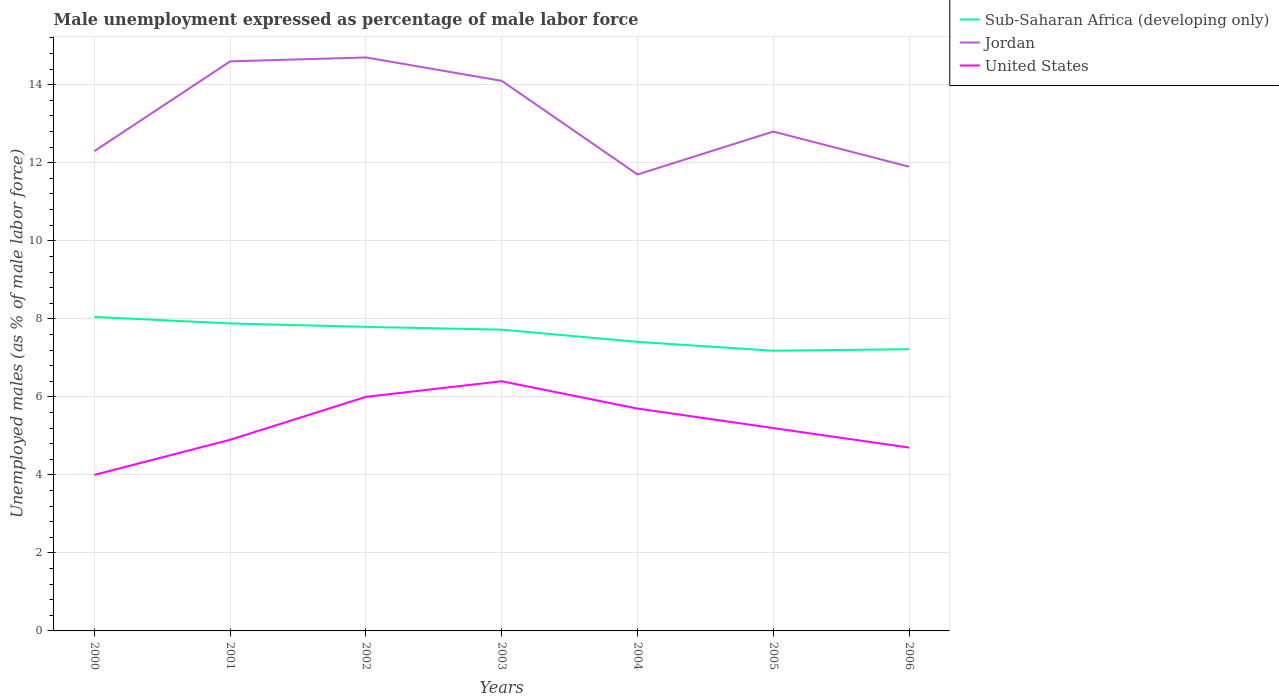How many different coloured lines are there?
Make the answer very short. 3. Across all years, what is the maximum unemployment in males in in Jordan?
Your answer should be compact. 11.7. What is the total unemployment in males in in Sub-Saharan Africa (developing only) in the graph?
Your answer should be compact. 0.09. What is the difference between the highest and the lowest unemployment in males in in Jordan?
Offer a terse response. 3. How many lines are there?
Your answer should be very brief. 3. How many years are there in the graph?
Give a very brief answer. 7. What is the difference between two consecutive major ticks on the Y-axis?
Your answer should be very brief. 2. Does the graph contain any zero values?
Provide a succinct answer. No. How many legend labels are there?
Your response must be concise. 3. How are the legend labels stacked?
Offer a very short reply. Vertical. What is the title of the graph?
Offer a terse response. Male unemployment expressed as percentage of male labor force. Does "Middle income" appear as one of the legend labels in the graph?
Give a very brief answer. No. What is the label or title of the Y-axis?
Offer a terse response. Unemployed males (as % of male labor force). What is the Unemployed males (as % of male labor force) of Sub-Saharan Africa (developing only) in 2000?
Make the answer very short. 8.05. What is the Unemployed males (as % of male labor force) of Jordan in 2000?
Your answer should be compact. 12.3. What is the Unemployed males (as % of male labor force) of United States in 2000?
Your answer should be compact. 4. What is the Unemployed males (as % of male labor force) in Sub-Saharan Africa (developing only) in 2001?
Give a very brief answer. 7.88. What is the Unemployed males (as % of male labor force) of Jordan in 2001?
Offer a very short reply. 14.6. What is the Unemployed males (as % of male labor force) of United States in 2001?
Your response must be concise. 4.9. What is the Unemployed males (as % of male labor force) of Sub-Saharan Africa (developing only) in 2002?
Your answer should be very brief. 7.79. What is the Unemployed males (as % of male labor force) of Jordan in 2002?
Your response must be concise. 14.7. What is the Unemployed males (as % of male labor force) of Sub-Saharan Africa (developing only) in 2003?
Provide a succinct answer. 7.72. What is the Unemployed males (as % of male labor force) of Jordan in 2003?
Your answer should be compact. 14.1. What is the Unemployed males (as % of male labor force) of United States in 2003?
Provide a succinct answer. 6.4. What is the Unemployed males (as % of male labor force) of Sub-Saharan Africa (developing only) in 2004?
Make the answer very short. 7.41. What is the Unemployed males (as % of male labor force) in Jordan in 2004?
Provide a short and direct response. 11.7. What is the Unemployed males (as % of male labor force) in United States in 2004?
Give a very brief answer. 5.7. What is the Unemployed males (as % of male labor force) in Sub-Saharan Africa (developing only) in 2005?
Your response must be concise. 7.18. What is the Unemployed males (as % of male labor force) of Jordan in 2005?
Your answer should be very brief. 12.8. What is the Unemployed males (as % of male labor force) of United States in 2005?
Keep it short and to the point. 5.2. What is the Unemployed males (as % of male labor force) in Sub-Saharan Africa (developing only) in 2006?
Keep it short and to the point. 7.22. What is the Unemployed males (as % of male labor force) in Jordan in 2006?
Offer a terse response. 11.9. What is the Unemployed males (as % of male labor force) of United States in 2006?
Make the answer very short. 4.7. Across all years, what is the maximum Unemployed males (as % of male labor force) of Sub-Saharan Africa (developing only)?
Offer a terse response. 8.05. Across all years, what is the maximum Unemployed males (as % of male labor force) in Jordan?
Keep it short and to the point. 14.7. Across all years, what is the maximum Unemployed males (as % of male labor force) in United States?
Your answer should be compact. 6.4. Across all years, what is the minimum Unemployed males (as % of male labor force) in Sub-Saharan Africa (developing only)?
Offer a very short reply. 7.18. Across all years, what is the minimum Unemployed males (as % of male labor force) of Jordan?
Keep it short and to the point. 11.7. What is the total Unemployed males (as % of male labor force) of Sub-Saharan Africa (developing only) in the graph?
Offer a terse response. 53.26. What is the total Unemployed males (as % of male labor force) of Jordan in the graph?
Your answer should be compact. 92.1. What is the total Unemployed males (as % of male labor force) in United States in the graph?
Your response must be concise. 36.9. What is the difference between the Unemployed males (as % of male labor force) of Sub-Saharan Africa (developing only) in 2000 and that in 2001?
Keep it short and to the point. 0.17. What is the difference between the Unemployed males (as % of male labor force) of Jordan in 2000 and that in 2001?
Ensure brevity in your answer.  -2.3. What is the difference between the Unemployed males (as % of male labor force) in Sub-Saharan Africa (developing only) in 2000 and that in 2002?
Offer a terse response. 0.25. What is the difference between the Unemployed males (as % of male labor force) in Jordan in 2000 and that in 2002?
Ensure brevity in your answer.  -2.4. What is the difference between the Unemployed males (as % of male labor force) in United States in 2000 and that in 2002?
Offer a terse response. -2. What is the difference between the Unemployed males (as % of male labor force) in Sub-Saharan Africa (developing only) in 2000 and that in 2003?
Keep it short and to the point. 0.33. What is the difference between the Unemployed males (as % of male labor force) in Sub-Saharan Africa (developing only) in 2000 and that in 2004?
Make the answer very short. 0.64. What is the difference between the Unemployed males (as % of male labor force) of United States in 2000 and that in 2004?
Offer a very short reply. -1.7. What is the difference between the Unemployed males (as % of male labor force) of Sub-Saharan Africa (developing only) in 2000 and that in 2005?
Offer a very short reply. 0.87. What is the difference between the Unemployed males (as % of male labor force) of Jordan in 2000 and that in 2005?
Your answer should be very brief. -0.5. What is the difference between the Unemployed males (as % of male labor force) in Sub-Saharan Africa (developing only) in 2000 and that in 2006?
Your response must be concise. 0.83. What is the difference between the Unemployed males (as % of male labor force) in Jordan in 2000 and that in 2006?
Provide a succinct answer. 0.4. What is the difference between the Unemployed males (as % of male labor force) of United States in 2000 and that in 2006?
Provide a succinct answer. -0.7. What is the difference between the Unemployed males (as % of male labor force) of Sub-Saharan Africa (developing only) in 2001 and that in 2002?
Your answer should be compact. 0.09. What is the difference between the Unemployed males (as % of male labor force) in Jordan in 2001 and that in 2002?
Your response must be concise. -0.1. What is the difference between the Unemployed males (as % of male labor force) of United States in 2001 and that in 2002?
Provide a short and direct response. -1.1. What is the difference between the Unemployed males (as % of male labor force) in Sub-Saharan Africa (developing only) in 2001 and that in 2003?
Keep it short and to the point. 0.16. What is the difference between the Unemployed males (as % of male labor force) in Jordan in 2001 and that in 2003?
Offer a very short reply. 0.5. What is the difference between the Unemployed males (as % of male labor force) of Sub-Saharan Africa (developing only) in 2001 and that in 2004?
Offer a very short reply. 0.47. What is the difference between the Unemployed males (as % of male labor force) of Jordan in 2001 and that in 2004?
Offer a terse response. 2.9. What is the difference between the Unemployed males (as % of male labor force) in United States in 2001 and that in 2004?
Ensure brevity in your answer.  -0.8. What is the difference between the Unemployed males (as % of male labor force) in Sub-Saharan Africa (developing only) in 2001 and that in 2005?
Provide a succinct answer. 0.7. What is the difference between the Unemployed males (as % of male labor force) of United States in 2001 and that in 2005?
Your answer should be compact. -0.3. What is the difference between the Unemployed males (as % of male labor force) in Sub-Saharan Africa (developing only) in 2001 and that in 2006?
Provide a short and direct response. 0.66. What is the difference between the Unemployed males (as % of male labor force) of Sub-Saharan Africa (developing only) in 2002 and that in 2003?
Make the answer very short. 0.07. What is the difference between the Unemployed males (as % of male labor force) in United States in 2002 and that in 2003?
Ensure brevity in your answer.  -0.4. What is the difference between the Unemployed males (as % of male labor force) in Sub-Saharan Africa (developing only) in 2002 and that in 2004?
Your answer should be very brief. 0.38. What is the difference between the Unemployed males (as % of male labor force) of Sub-Saharan Africa (developing only) in 2002 and that in 2005?
Your answer should be compact. 0.61. What is the difference between the Unemployed males (as % of male labor force) of Sub-Saharan Africa (developing only) in 2002 and that in 2006?
Make the answer very short. 0.57. What is the difference between the Unemployed males (as % of male labor force) in Jordan in 2002 and that in 2006?
Offer a terse response. 2.8. What is the difference between the Unemployed males (as % of male labor force) in Sub-Saharan Africa (developing only) in 2003 and that in 2004?
Provide a short and direct response. 0.31. What is the difference between the Unemployed males (as % of male labor force) of United States in 2003 and that in 2004?
Make the answer very short. 0.7. What is the difference between the Unemployed males (as % of male labor force) of Sub-Saharan Africa (developing only) in 2003 and that in 2005?
Make the answer very short. 0.54. What is the difference between the Unemployed males (as % of male labor force) in Jordan in 2003 and that in 2005?
Provide a short and direct response. 1.3. What is the difference between the Unemployed males (as % of male labor force) of Sub-Saharan Africa (developing only) in 2003 and that in 2006?
Provide a succinct answer. 0.5. What is the difference between the Unemployed males (as % of male labor force) in Sub-Saharan Africa (developing only) in 2004 and that in 2005?
Give a very brief answer. 0.23. What is the difference between the Unemployed males (as % of male labor force) in United States in 2004 and that in 2005?
Your answer should be very brief. 0.5. What is the difference between the Unemployed males (as % of male labor force) of Sub-Saharan Africa (developing only) in 2004 and that in 2006?
Provide a short and direct response. 0.19. What is the difference between the Unemployed males (as % of male labor force) in Jordan in 2004 and that in 2006?
Offer a very short reply. -0.2. What is the difference between the Unemployed males (as % of male labor force) of Sub-Saharan Africa (developing only) in 2005 and that in 2006?
Give a very brief answer. -0.04. What is the difference between the Unemployed males (as % of male labor force) of United States in 2005 and that in 2006?
Make the answer very short. 0.5. What is the difference between the Unemployed males (as % of male labor force) in Sub-Saharan Africa (developing only) in 2000 and the Unemployed males (as % of male labor force) in Jordan in 2001?
Make the answer very short. -6.55. What is the difference between the Unemployed males (as % of male labor force) in Sub-Saharan Africa (developing only) in 2000 and the Unemployed males (as % of male labor force) in United States in 2001?
Offer a very short reply. 3.15. What is the difference between the Unemployed males (as % of male labor force) in Sub-Saharan Africa (developing only) in 2000 and the Unemployed males (as % of male labor force) in Jordan in 2002?
Your answer should be very brief. -6.65. What is the difference between the Unemployed males (as % of male labor force) of Sub-Saharan Africa (developing only) in 2000 and the Unemployed males (as % of male labor force) of United States in 2002?
Your response must be concise. 2.05. What is the difference between the Unemployed males (as % of male labor force) of Sub-Saharan Africa (developing only) in 2000 and the Unemployed males (as % of male labor force) of Jordan in 2003?
Provide a succinct answer. -6.05. What is the difference between the Unemployed males (as % of male labor force) of Sub-Saharan Africa (developing only) in 2000 and the Unemployed males (as % of male labor force) of United States in 2003?
Your response must be concise. 1.65. What is the difference between the Unemployed males (as % of male labor force) of Jordan in 2000 and the Unemployed males (as % of male labor force) of United States in 2003?
Offer a terse response. 5.9. What is the difference between the Unemployed males (as % of male labor force) in Sub-Saharan Africa (developing only) in 2000 and the Unemployed males (as % of male labor force) in Jordan in 2004?
Keep it short and to the point. -3.65. What is the difference between the Unemployed males (as % of male labor force) in Sub-Saharan Africa (developing only) in 2000 and the Unemployed males (as % of male labor force) in United States in 2004?
Keep it short and to the point. 2.35. What is the difference between the Unemployed males (as % of male labor force) in Sub-Saharan Africa (developing only) in 2000 and the Unemployed males (as % of male labor force) in Jordan in 2005?
Keep it short and to the point. -4.75. What is the difference between the Unemployed males (as % of male labor force) of Sub-Saharan Africa (developing only) in 2000 and the Unemployed males (as % of male labor force) of United States in 2005?
Your answer should be very brief. 2.85. What is the difference between the Unemployed males (as % of male labor force) of Jordan in 2000 and the Unemployed males (as % of male labor force) of United States in 2005?
Provide a short and direct response. 7.1. What is the difference between the Unemployed males (as % of male labor force) in Sub-Saharan Africa (developing only) in 2000 and the Unemployed males (as % of male labor force) in Jordan in 2006?
Give a very brief answer. -3.85. What is the difference between the Unemployed males (as % of male labor force) of Sub-Saharan Africa (developing only) in 2000 and the Unemployed males (as % of male labor force) of United States in 2006?
Your response must be concise. 3.35. What is the difference between the Unemployed males (as % of male labor force) in Sub-Saharan Africa (developing only) in 2001 and the Unemployed males (as % of male labor force) in Jordan in 2002?
Your response must be concise. -6.82. What is the difference between the Unemployed males (as % of male labor force) in Sub-Saharan Africa (developing only) in 2001 and the Unemployed males (as % of male labor force) in United States in 2002?
Provide a succinct answer. 1.88. What is the difference between the Unemployed males (as % of male labor force) of Jordan in 2001 and the Unemployed males (as % of male labor force) of United States in 2002?
Offer a terse response. 8.6. What is the difference between the Unemployed males (as % of male labor force) in Sub-Saharan Africa (developing only) in 2001 and the Unemployed males (as % of male labor force) in Jordan in 2003?
Your answer should be very brief. -6.22. What is the difference between the Unemployed males (as % of male labor force) of Sub-Saharan Africa (developing only) in 2001 and the Unemployed males (as % of male labor force) of United States in 2003?
Give a very brief answer. 1.48. What is the difference between the Unemployed males (as % of male labor force) in Sub-Saharan Africa (developing only) in 2001 and the Unemployed males (as % of male labor force) in Jordan in 2004?
Your answer should be compact. -3.82. What is the difference between the Unemployed males (as % of male labor force) of Sub-Saharan Africa (developing only) in 2001 and the Unemployed males (as % of male labor force) of United States in 2004?
Your answer should be compact. 2.18. What is the difference between the Unemployed males (as % of male labor force) of Sub-Saharan Africa (developing only) in 2001 and the Unemployed males (as % of male labor force) of Jordan in 2005?
Make the answer very short. -4.92. What is the difference between the Unemployed males (as % of male labor force) of Sub-Saharan Africa (developing only) in 2001 and the Unemployed males (as % of male labor force) of United States in 2005?
Your response must be concise. 2.68. What is the difference between the Unemployed males (as % of male labor force) of Jordan in 2001 and the Unemployed males (as % of male labor force) of United States in 2005?
Provide a short and direct response. 9.4. What is the difference between the Unemployed males (as % of male labor force) in Sub-Saharan Africa (developing only) in 2001 and the Unemployed males (as % of male labor force) in Jordan in 2006?
Your response must be concise. -4.02. What is the difference between the Unemployed males (as % of male labor force) of Sub-Saharan Africa (developing only) in 2001 and the Unemployed males (as % of male labor force) of United States in 2006?
Offer a very short reply. 3.18. What is the difference between the Unemployed males (as % of male labor force) in Jordan in 2001 and the Unemployed males (as % of male labor force) in United States in 2006?
Your response must be concise. 9.9. What is the difference between the Unemployed males (as % of male labor force) of Sub-Saharan Africa (developing only) in 2002 and the Unemployed males (as % of male labor force) of Jordan in 2003?
Ensure brevity in your answer.  -6.31. What is the difference between the Unemployed males (as % of male labor force) of Sub-Saharan Africa (developing only) in 2002 and the Unemployed males (as % of male labor force) of United States in 2003?
Keep it short and to the point. 1.39. What is the difference between the Unemployed males (as % of male labor force) of Jordan in 2002 and the Unemployed males (as % of male labor force) of United States in 2003?
Your answer should be compact. 8.3. What is the difference between the Unemployed males (as % of male labor force) of Sub-Saharan Africa (developing only) in 2002 and the Unemployed males (as % of male labor force) of Jordan in 2004?
Give a very brief answer. -3.91. What is the difference between the Unemployed males (as % of male labor force) of Sub-Saharan Africa (developing only) in 2002 and the Unemployed males (as % of male labor force) of United States in 2004?
Ensure brevity in your answer.  2.09. What is the difference between the Unemployed males (as % of male labor force) of Jordan in 2002 and the Unemployed males (as % of male labor force) of United States in 2004?
Ensure brevity in your answer.  9. What is the difference between the Unemployed males (as % of male labor force) of Sub-Saharan Africa (developing only) in 2002 and the Unemployed males (as % of male labor force) of Jordan in 2005?
Make the answer very short. -5.01. What is the difference between the Unemployed males (as % of male labor force) of Sub-Saharan Africa (developing only) in 2002 and the Unemployed males (as % of male labor force) of United States in 2005?
Your answer should be compact. 2.59. What is the difference between the Unemployed males (as % of male labor force) of Jordan in 2002 and the Unemployed males (as % of male labor force) of United States in 2005?
Offer a very short reply. 9.5. What is the difference between the Unemployed males (as % of male labor force) of Sub-Saharan Africa (developing only) in 2002 and the Unemployed males (as % of male labor force) of Jordan in 2006?
Your response must be concise. -4.11. What is the difference between the Unemployed males (as % of male labor force) in Sub-Saharan Africa (developing only) in 2002 and the Unemployed males (as % of male labor force) in United States in 2006?
Your response must be concise. 3.09. What is the difference between the Unemployed males (as % of male labor force) of Sub-Saharan Africa (developing only) in 2003 and the Unemployed males (as % of male labor force) of Jordan in 2004?
Your answer should be very brief. -3.98. What is the difference between the Unemployed males (as % of male labor force) of Sub-Saharan Africa (developing only) in 2003 and the Unemployed males (as % of male labor force) of United States in 2004?
Your answer should be very brief. 2.02. What is the difference between the Unemployed males (as % of male labor force) in Jordan in 2003 and the Unemployed males (as % of male labor force) in United States in 2004?
Provide a short and direct response. 8.4. What is the difference between the Unemployed males (as % of male labor force) of Sub-Saharan Africa (developing only) in 2003 and the Unemployed males (as % of male labor force) of Jordan in 2005?
Your answer should be very brief. -5.08. What is the difference between the Unemployed males (as % of male labor force) in Sub-Saharan Africa (developing only) in 2003 and the Unemployed males (as % of male labor force) in United States in 2005?
Your response must be concise. 2.52. What is the difference between the Unemployed males (as % of male labor force) in Sub-Saharan Africa (developing only) in 2003 and the Unemployed males (as % of male labor force) in Jordan in 2006?
Ensure brevity in your answer.  -4.18. What is the difference between the Unemployed males (as % of male labor force) of Sub-Saharan Africa (developing only) in 2003 and the Unemployed males (as % of male labor force) of United States in 2006?
Offer a very short reply. 3.02. What is the difference between the Unemployed males (as % of male labor force) in Jordan in 2003 and the Unemployed males (as % of male labor force) in United States in 2006?
Give a very brief answer. 9.4. What is the difference between the Unemployed males (as % of male labor force) in Sub-Saharan Africa (developing only) in 2004 and the Unemployed males (as % of male labor force) in Jordan in 2005?
Your response must be concise. -5.39. What is the difference between the Unemployed males (as % of male labor force) in Sub-Saharan Africa (developing only) in 2004 and the Unemployed males (as % of male labor force) in United States in 2005?
Provide a short and direct response. 2.21. What is the difference between the Unemployed males (as % of male labor force) in Jordan in 2004 and the Unemployed males (as % of male labor force) in United States in 2005?
Ensure brevity in your answer.  6.5. What is the difference between the Unemployed males (as % of male labor force) of Sub-Saharan Africa (developing only) in 2004 and the Unemployed males (as % of male labor force) of Jordan in 2006?
Your answer should be very brief. -4.49. What is the difference between the Unemployed males (as % of male labor force) of Sub-Saharan Africa (developing only) in 2004 and the Unemployed males (as % of male labor force) of United States in 2006?
Provide a short and direct response. 2.71. What is the difference between the Unemployed males (as % of male labor force) of Sub-Saharan Africa (developing only) in 2005 and the Unemployed males (as % of male labor force) of Jordan in 2006?
Give a very brief answer. -4.72. What is the difference between the Unemployed males (as % of male labor force) of Sub-Saharan Africa (developing only) in 2005 and the Unemployed males (as % of male labor force) of United States in 2006?
Offer a very short reply. 2.48. What is the average Unemployed males (as % of male labor force) of Sub-Saharan Africa (developing only) per year?
Provide a short and direct response. 7.61. What is the average Unemployed males (as % of male labor force) in Jordan per year?
Provide a short and direct response. 13.16. What is the average Unemployed males (as % of male labor force) of United States per year?
Offer a terse response. 5.27. In the year 2000, what is the difference between the Unemployed males (as % of male labor force) in Sub-Saharan Africa (developing only) and Unemployed males (as % of male labor force) in Jordan?
Your response must be concise. -4.25. In the year 2000, what is the difference between the Unemployed males (as % of male labor force) of Sub-Saharan Africa (developing only) and Unemployed males (as % of male labor force) of United States?
Offer a very short reply. 4.05. In the year 2000, what is the difference between the Unemployed males (as % of male labor force) of Jordan and Unemployed males (as % of male labor force) of United States?
Offer a very short reply. 8.3. In the year 2001, what is the difference between the Unemployed males (as % of male labor force) in Sub-Saharan Africa (developing only) and Unemployed males (as % of male labor force) in Jordan?
Provide a short and direct response. -6.72. In the year 2001, what is the difference between the Unemployed males (as % of male labor force) in Sub-Saharan Africa (developing only) and Unemployed males (as % of male labor force) in United States?
Offer a very short reply. 2.98. In the year 2001, what is the difference between the Unemployed males (as % of male labor force) of Jordan and Unemployed males (as % of male labor force) of United States?
Provide a short and direct response. 9.7. In the year 2002, what is the difference between the Unemployed males (as % of male labor force) in Sub-Saharan Africa (developing only) and Unemployed males (as % of male labor force) in Jordan?
Provide a short and direct response. -6.91. In the year 2002, what is the difference between the Unemployed males (as % of male labor force) in Sub-Saharan Africa (developing only) and Unemployed males (as % of male labor force) in United States?
Make the answer very short. 1.79. In the year 2002, what is the difference between the Unemployed males (as % of male labor force) in Jordan and Unemployed males (as % of male labor force) in United States?
Offer a very short reply. 8.7. In the year 2003, what is the difference between the Unemployed males (as % of male labor force) of Sub-Saharan Africa (developing only) and Unemployed males (as % of male labor force) of Jordan?
Make the answer very short. -6.38. In the year 2003, what is the difference between the Unemployed males (as % of male labor force) in Sub-Saharan Africa (developing only) and Unemployed males (as % of male labor force) in United States?
Keep it short and to the point. 1.32. In the year 2003, what is the difference between the Unemployed males (as % of male labor force) in Jordan and Unemployed males (as % of male labor force) in United States?
Your response must be concise. 7.7. In the year 2004, what is the difference between the Unemployed males (as % of male labor force) of Sub-Saharan Africa (developing only) and Unemployed males (as % of male labor force) of Jordan?
Your response must be concise. -4.29. In the year 2004, what is the difference between the Unemployed males (as % of male labor force) of Sub-Saharan Africa (developing only) and Unemployed males (as % of male labor force) of United States?
Provide a succinct answer. 1.71. In the year 2004, what is the difference between the Unemployed males (as % of male labor force) in Jordan and Unemployed males (as % of male labor force) in United States?
Your answer should be compact. 6. In the year 2005, what is the difference between the Unemployed males (as % of male labor force) in Sub-Saharan Africa (developing only) and Unemployed males (as % of male labor force) in Jordan?
Your answer should be compact. -5.62. In the year 2005, what is the difference between the Unemployed males (as % of male labor force) in Sub-Saharan Africa (developing only) and Unemployed males (as % of male labor force) in United States?
Provide a succinct answer. 1.98. In the year 2005, what is the difference between the Unemployed males (as % of male labor force) in Jordan and Unemployed males (as % of male labor force) in United States?
Your response must be concise. 7.6. In the year 2006, what is the difference between the Unemployed males (as % of male labor force) of Sub-Saharan Africa (developing only) and Unemployed males (as % of male labor force) of Jordan?
Keep it short and to the point. -4.68. In the year 2006, what is the difference between the Unemployed males (as % of male labor force) of Sub-Saharan Africa (developing only) and Unemployed males (as % of male labor force) of United States?
Keep it short and to the point. 2.52. In the year 2006, what is the difference between the Unemployed males (as % of male labor force) in Jordan and Unemployed males (as % of male labor force) in United States?
Make the answer very short. 7.2. What is the ratio of the Unemployed males (as % of male labor force) of Sub-Saharan Africa (developing only) in 2000 to that in 2001?
Provide a succinct answer. 1.02. What is the ratio of the Unemployed males (as % of male labor force) in Jordan in 2000 to that in 2001?
Keep it short and to the point. 0.84. What is the ratio of the Unemployed males (as % of male labor force) in United States in 2000 to that in 2001?
Keep it short and to the point. 0.82. What is the ratio of the Unemployed males (as % of male labor force) of Sub-Saharan Africa (developing only) in 2000 to that in 2002?
Keep it short and to the point. 1.03. What is the ratio of the Unemployed males (as % of male labor force) of Jordan in 2000 to that in 2002?
Your response must be concise. 0.84. What is the ratio of the Unemployed males (as % of male labor force) of Sub-Saharan Africa (developing only) in 2000 to that in 2003?
Your answer should be compact. 1.04. What is the ratio of the Unemployed males (as % of male labor force) of Jordan in 2000 to that in 2003?
Provide a succinct answer. 0.87. What is the ratio of the Unemployed males (as % of male labor force) of Sub-Saharan Africa (developing only) in 2000 to that in 2004?
Ensure brevity in your answer.  1.09. What is the ratio of the Unemployed males (as % of male labor force) of Jordan in 2000 to that in 2004?
Keep it short and to the point. 1.05. What is the ratio of the Unemployed males (as % of male labor force) of United States in 2000 to that in 2004?
Your response must be concise. 0.7. What is the ratio of the Unemployed males (as % of male labor force) in Sub-Saharan Africa (developing only) in 2000 to that in 2005?
Give a very brief answer. 1.12. What is the ratio of the Unemployed males (as % of male labor force) of Jordan in 2000 to that in 2005?
Offer a terse response. 0.96. What is the ratio of the Unemployed males (as % of male labor force) of United States in 2000 to that in 2005?
Offer a terse response. 0.77. What is the ratio of the Unemployed males (as % of male labor force) of Sub-Saharan Africa (developing only) in 2000 to that in 2006?
Provide a short and direct response. 1.11. What is the ratio of the Unemployed males (as % of male labor force) in Jordan in 2000 to that in 2006?
Your answer should be very brief. 1.03. What is the ratio of the Unemployed males (as % of male labor force) in United States in 2000 to that in 2006?
Your response must be concise. 0.85. What is the ratio of the Unemployed males (as % of male labor force) of Sub-Saharan Africa (developing only) in 2001 to that in 2002?
Give a very brief answer. 1.01. What is the ratio of the Unemployed males (as % of male labor force) in United States in 2001 to that in 2002?
Your answer should be very brief. 0.82. What is the ratio of the Unemployed males (as % of male labor force) in Sub-Saharan Africa (developing only) in 2001 to that in 2003?
Give a very brief answer. 1.02. What is the ratio of the Unemployed males (as % of male labor force) of Jordan in 2001 to that in 2003?
Offer a terse response. 1.04. What is the ratio of the Unemployed males (as % of male labor force) in United States in 2001 to that in 2003?
Provide a succinct answer. 0.77. What is the ratio of the Unemployed males (as % of male labor force) of Sub-Saharan Africa (developing only) in 2001 to that in 2004?
Your answer should be compact. 1.06. What is the ratio of the Unemployed males (as % of male labor force) in Jordan in 2001 to that in 2004?
Offer a very short reply. 1.25. What is the ratio of the Unemployed males (as % of male labor force) in United States in 2001 to that in 2004?
Your answer should be compact. 0.86. What is the ratio of the Unemployed males (as % of male labor force) in Sub-Saharan Africa (developing only) in 2001 to that in 2005?
Make the answer very short. 1.1. What is the ratio of the Unemployed males (as % of male labor force) of Jordan in 2001 to that in 2005?
Your answer should be very brief. 1.14. What is the ratio of the Unemployed males (as % of male labor force) of United States in 2001 to that in 2005?
Make the answer very short. 0.94. What is the ratio of the Unemployed males (as % of male labor force) in Sub-Saharan Africa (developing only) in 2001 to that in 2006?
Provide a succinct answer. 1.09. What is the ratio of the Unemployed males (as % of male labor force) in Jordan in 2001 to that in 2006?
Ensure brevity in your answer.  1.23. What is the ratio of the Unemployed males (as % of male labor force) of United States in 2001 to that in 2006?
Your response must be concise. 1.04. What is the ratio of the Unemployed males (as % of male labor force) of Sub-Saharan Africa (developing only) in 2002 to that in 2003?
Make the answer very short. 1.01. What is the ratio of the Unemployed males (as % of male labor force) in Jordan in 2002 to that in 2003?
Provide a succinct answer. 1.04. What is the ratio of the Unemployed males (as % of male labor force) of Sub-Saharan Africa (developing only) in 2002 to that in 2004?
Your answer should be compact. 1.05. What is the ratio of the Unemployed males (as % of male labor force) in Jordan in 2002 to that in 2004?
Make the answer very short. 1.26. What is the ratio of the Unemployed males (as % of male labor force) of United States in 2002 to that in 2004?
Offer a very short reply. 1.05. What is the ratio of the Unemployed males (as % of male labor force) in Sub-Saharan Africa (developing only) in 2002 to that in 2005?
Keep it short and to the point. 1.09. What is the ratio of the Unemployed males (as % of male labor force) of Jordan in 2002 to that in 2005?
Your answer should be very brief. 1.15. What is the ratio of the Unemployed males (as % of male labor force) in United States in 2002 to that in 2005?
Your answer should be very brief. 1.15. What is the ratio of the Unemployed males (as % of male labor force) in Sub-Saharan Africa (developing only) in 2002 to that in 2006?
Ensure brevity in your answer.  1.08. What is the ratio of the Unemployed males (as % of male labor force) of Jordan in 2002 to that in 2006?
Make the answer very short. 1.24. What is the ratio of the Unemployed males (as % of male labor force) of United States in 2002 to that in 2006?
Offer a very short reply. 1.28. What is the ratio of the Unemployed males (as % of male labor force) of Sub-Saharan Africa (developing only) in 2003 to that in 2004?
Offer a terse response. 1.04. What is the ratio of the Unemployed males (as % of male labor force) in Jordan in 2003 to that in 2004?
Keep it short and to the point. 1.21. What is the ratio of the Unemployed males (as % of male labor force) of United States in 2003 to that in 2004?
Offer a terse response. 1.12. What is the ratio of the Unemployed males (as % of male labor force) in Sub-Saharan Africa (developing only) in 2003 to that in 2005?
Keep it short and to the point. 1.08. What is the ratio of the Unemployed males (as % of male labor force) of Jordan in 2003 to that in 2005?
Provide a succinct answer. 1.1. What is the ratio of the Unemployed males (as % of male labor force) in United States in 2003 to that in 2005?
Give a very brief answer. 1.23. What is the ratio of the Unemployed males (as % of male labor force) of Sub-Saharan Africa (developing only) in 2003 to that in 2006?
Make the answer very short. 1.07. What is the ratio of the Unemployed males (as % of male labor force) in Jordan in 2003 to that in 2006?
Make the answer very short. 1.18. What is the ratio of the Unemployed males (as % of male labor force) of United States in 2003 to that in 2006?
Offer a terse response. 1.36. What is the ratio of the Unemployed males (as % of male labor force) in Sub-Saharan Africa (developing only) in 2004 to that in 2005?
Provide a short and direct response. 1.03. What is the ratio of the Unemployed males (as % of male labor force) of Jordan in 2004 to that in 2005?
Your answer should be compact. 0.91. What is the ratio of the Unemployed males (as % of male labor force) of United States in 2004 to that in 2005?
Your response must be concise. 1.1. What is the ratio of the Unemployed males (as % of male labor force) of Sub-Saharan Africa (developing only) in 2004 to that in 2006?
Offer a terse response. 1.03. What is the ratio of the Unemployed males (as % of male labor force) of Jordan in 2004 to that in 2006?
Ensure brevity in your answer.  0.98. What is the ratio of the Unemployed males (as % of male labor force) in United States in 2004 to that in 2006?
Offer a very short reply. 1.21. What is the ratio of the Unemployed males (as % of male labor force) in Sub-Saharan Africa (developing only) in 2005 to that in 2006?
Your answer should be very brief. 0.99. What is the ratio of the Unemployed males (as % of male labor force) in Jordan in 2005 to that in 2006?
Make the answer very short. 1.08. What is the ratio of the Unemployed males (as % of male labor force) of United States in 2005 to that in 2006?
Keep it short and to the point. 1.11. What is the difference between the highest and the second highest Unemployed males (as % of male labor force) of Sub-Saharan Africa (developing only)?
Give a very brief answer. 0.17. What is the difference between the highest and the lowest Unemployed males (as % of male labor force) in Sub-Saharan Africa (developing only)?
Make the answer very short. 0.87. What is the difference between the highest and the lowest Unemployed males (as % of male labor force) in United States?
Your response must be concise. 2.4. 